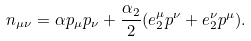Convert formula to latex. <formula><loc_0><loc_0><loc_500><loc_500>n _ { \mu \nu } = \alpha p _ { \mu } p _ { \nu } + \frac { \alpha _ { 2 } } { 2 } ( e ^ { \mu } _ { 2 } p ^ { \nu } + e _ { 2 } ^ { \nu } p ^ { \mu } ) .</formula> 